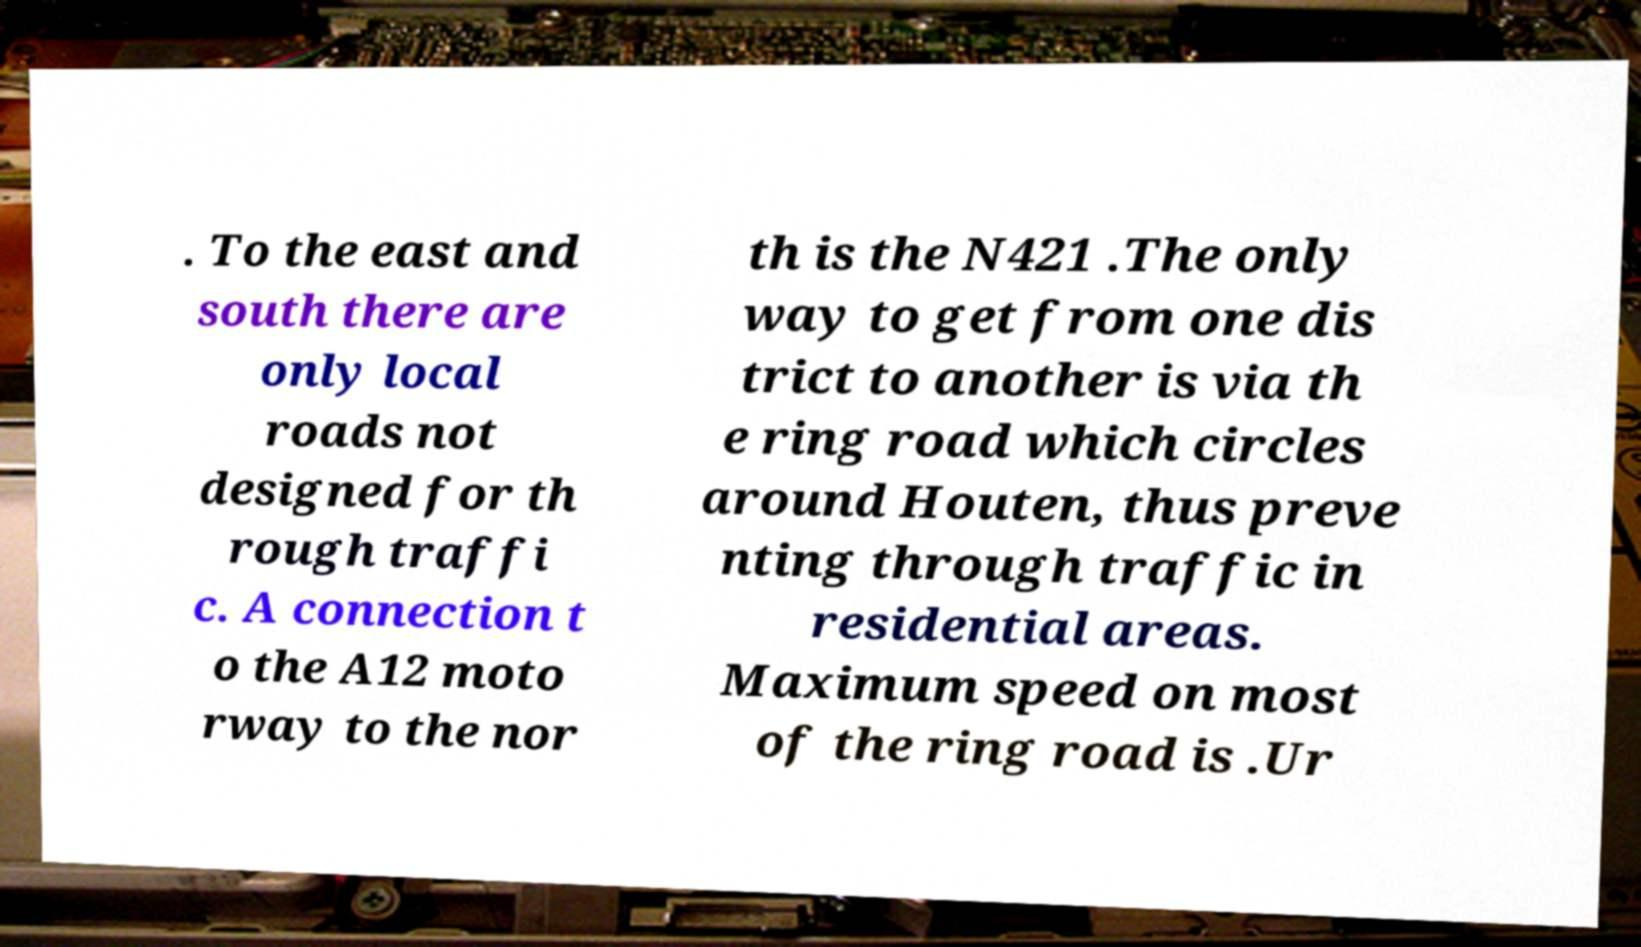Can you accurately transcribe the text from the provided image for me? . To the east and south there are only local roads not designed for th rough traffi c. A connection t o the A12 moto rway to the nor th is the N421 .The only way to get from one dis trict to another is via th e ring road which circles around Houten, thus preve nting through traffic in residential areas. Maximum speed on most of the ring road is .Ur 